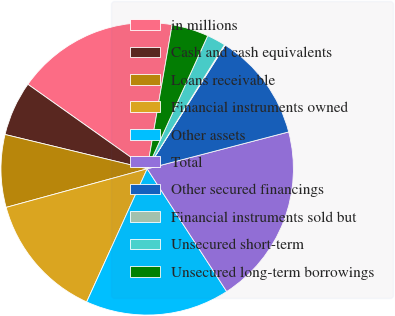Convert chart to OTSL. <chart><loc_0><loc_0><loc_500><loc_500><pie_chart><fcel>in millions<fcel>Cash and cash equivalents<fcel>Loans receivable<fcel>Financial instruments owned<fcel>Other assets<fcel>Total<fcel>Other secured financings<fcel>Financial instruments sold but<fcel>Unsecured short-term<fcel>Unsecured long-term borrowings<nl><fcel>17.92%<fcel>6.04%<fcel>8.02%<fcel>13.96%<fcel>15.94%<fcel>19.91%<fcel>11.98%<fcel>0.09%<fcel>2.08%<fcel>4.06%<nl></chart> 